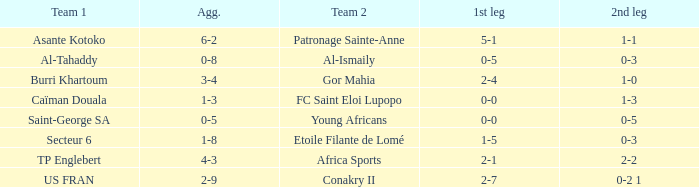Which team was defeated with scores of 0-3 and 0-5? Al-Tahaddy. 